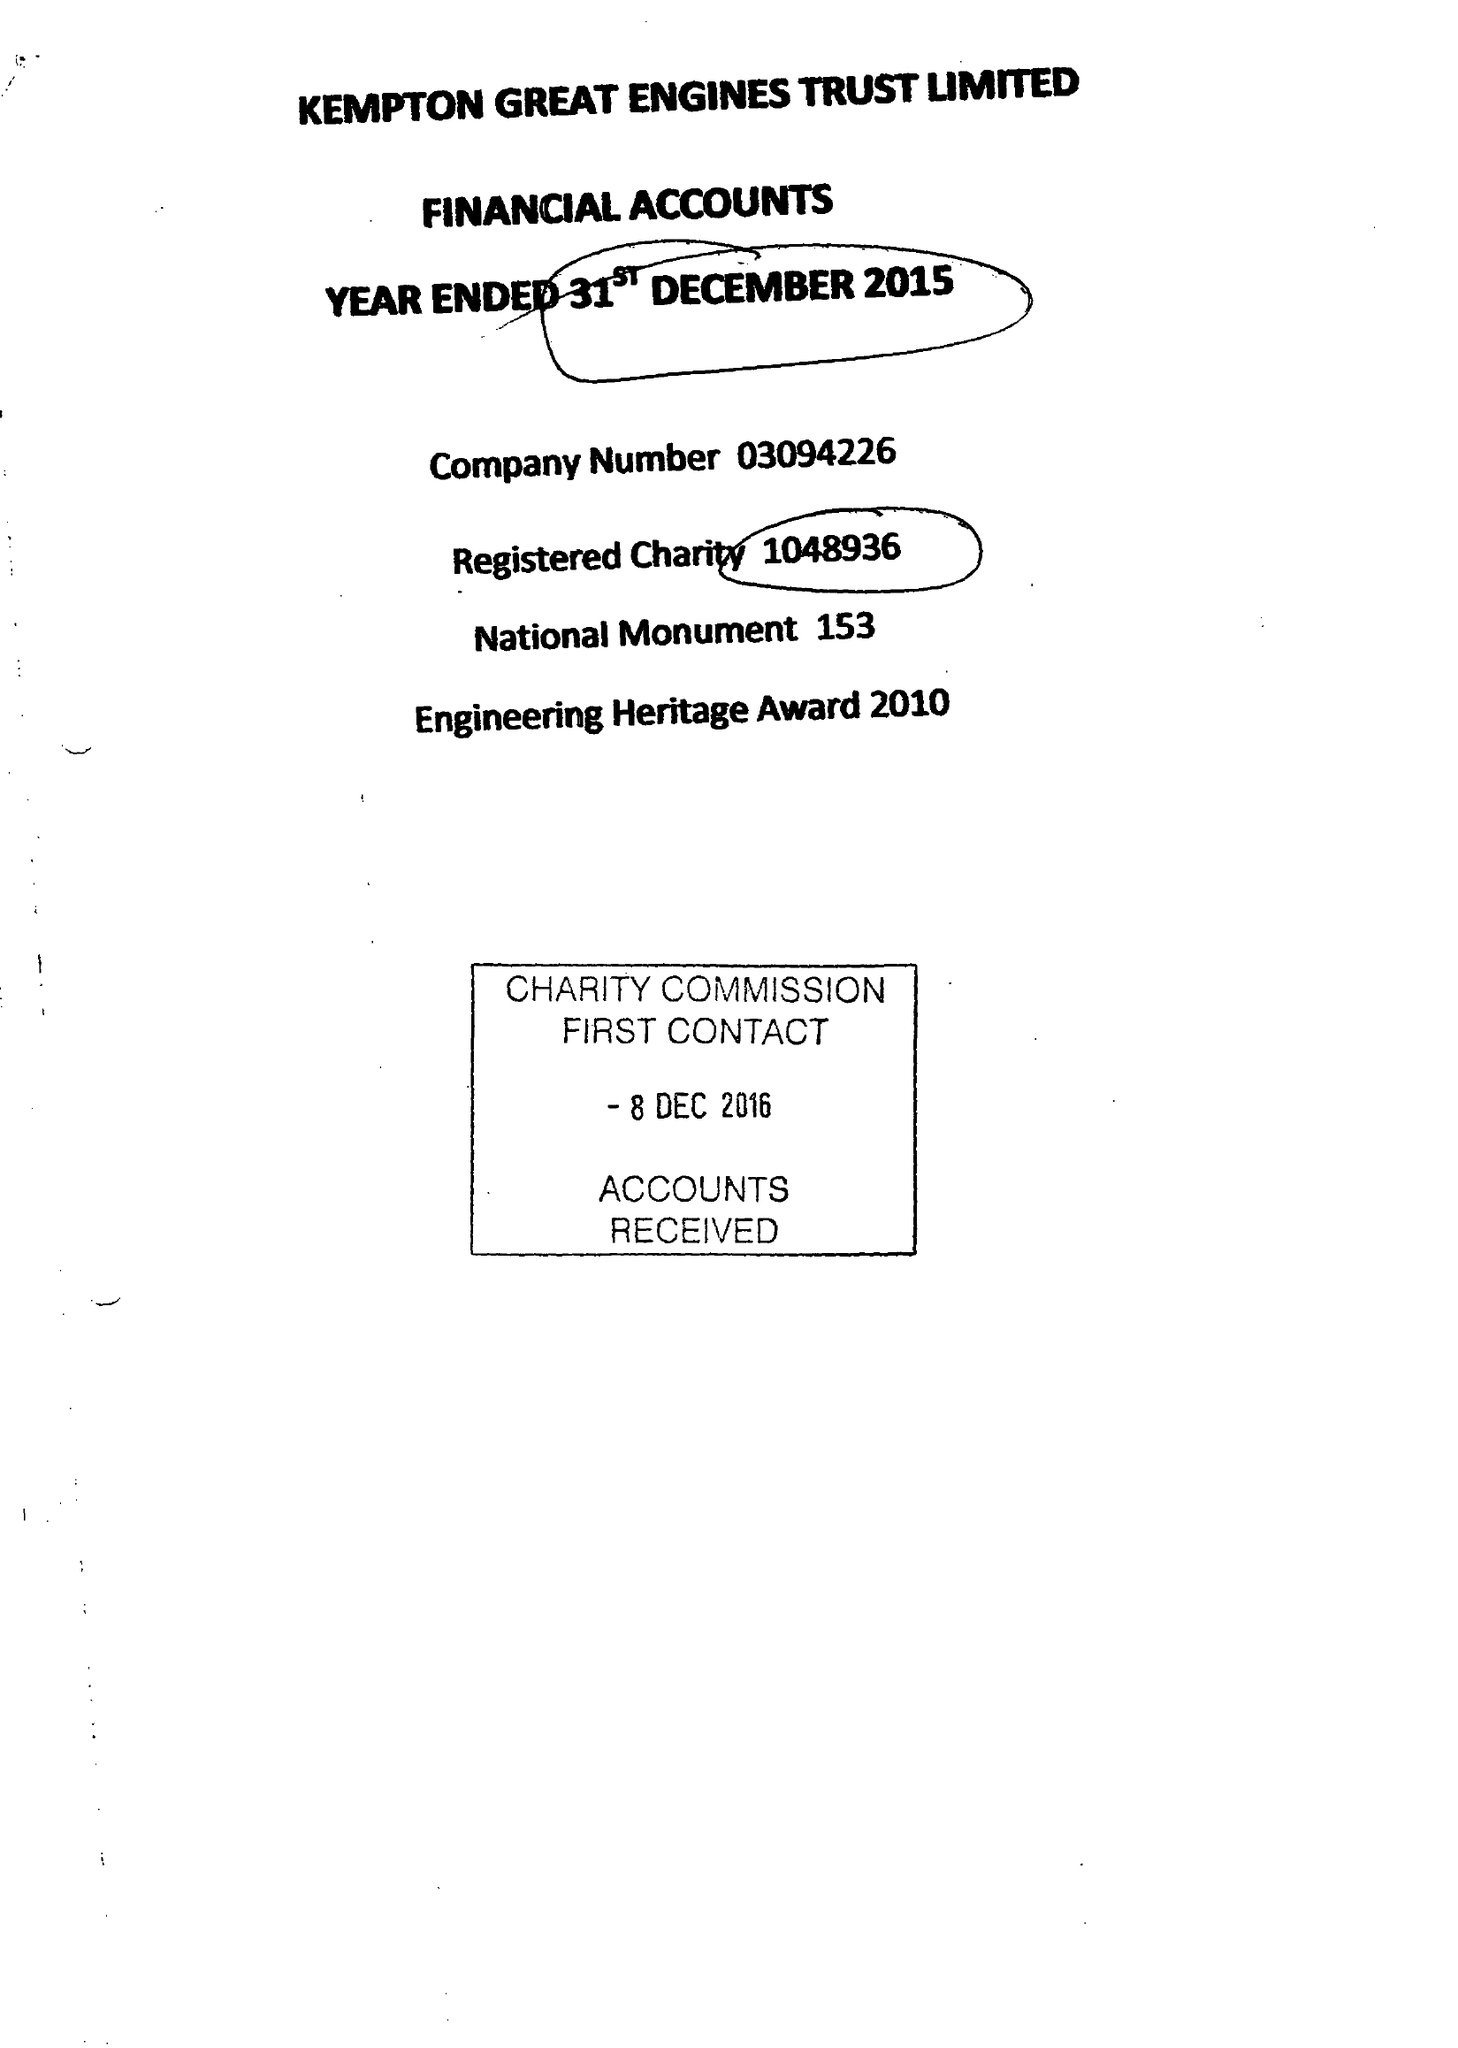What is the value for the address__postcode?
Answer the question using a single word or phrase. TW13 6XH 